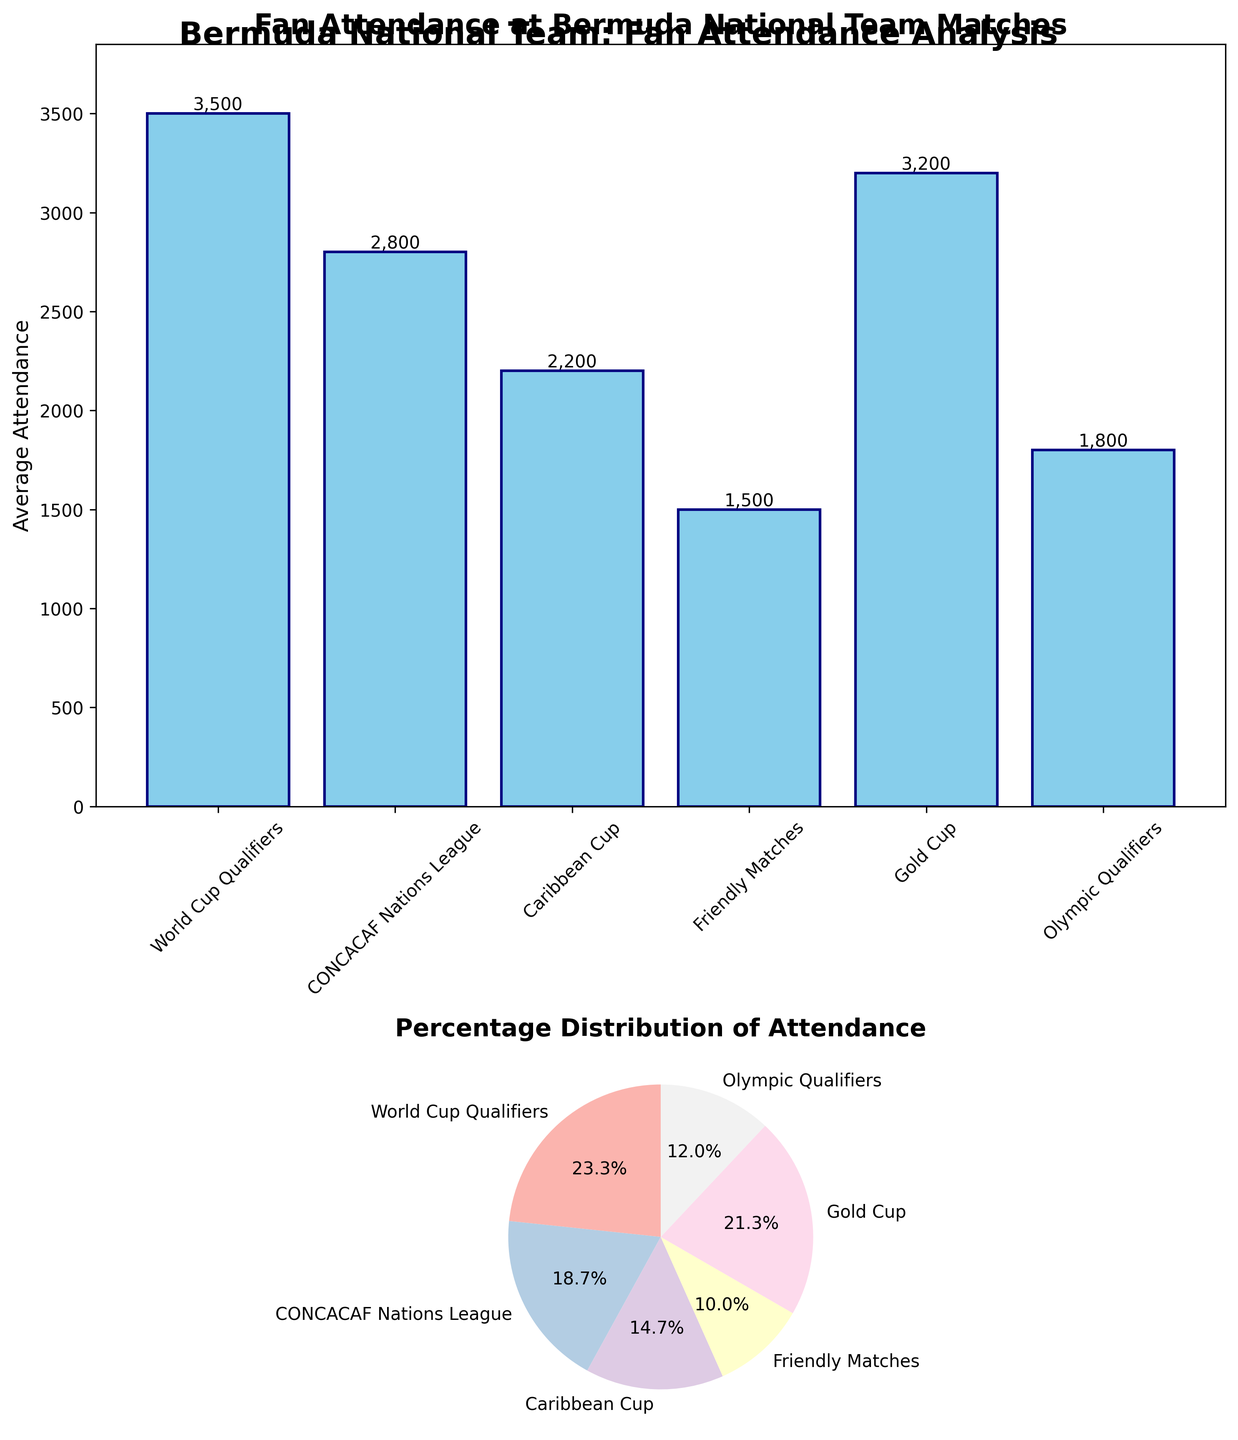How many different competitions are shown in the bar plot? There are 6 different labels on the x-axis of the bar plot, each representing a distinct competition.
Answer: 6 Which competition has the highest average attendance? By looking at the heights of the bars, the tallest bar corresponds to the 'World Cup Qualifiers'.
Answer: World Cup Qualifiers How much higher is the average attendance for 'World Cup Qualifiers' compared to 'Friendly Matches'? The average attendance for 'World Cup Qualifiers' is 3500, and for 'Friendly Matches' it is 1500. The difference is 3500 - 1500.
Answer: 2000 What is the combined average attendance for 'Gold Cup' and 'CONCACAF Nations League'? The average attendance for 'Gold Cup' is 3200, and for 'CONCACAF Nations League' it is 2800. The combined attendance is 3200 + 2800.
Answer: 6000 Which competition has the smallest percentage of total attendance? In the pie chart, the smallest segment corresponds to 'Friendly Matches'.
Answer: Friendly Matches What percentage of total attendance is attributed to 'World Cup Qualifiers'? 'World Cup Qualifiers' has an attendance of 3500. The total attendance sums to 15,000. The percentage is calculated as (3500/15000) * 100.
Answer: 23.3% Compare the attendance for 'Olympic Qualifiers' and 'Caribbean Cup'. Which one is higher? In the bar plot, the bar for 'Caribbean Cup' (2200) is higher than the bar for 'Olympic Qualifiers' (1800).
Answer: Caribbean Cup What's the average of the average attendance across all competitions? Sum all average attendances: 3500 + 2800 + 2200 + 1500 + 3200 + 1800 = 15000. There are 6 competitions. The average is 15000 / 6.
Answer: 2500 